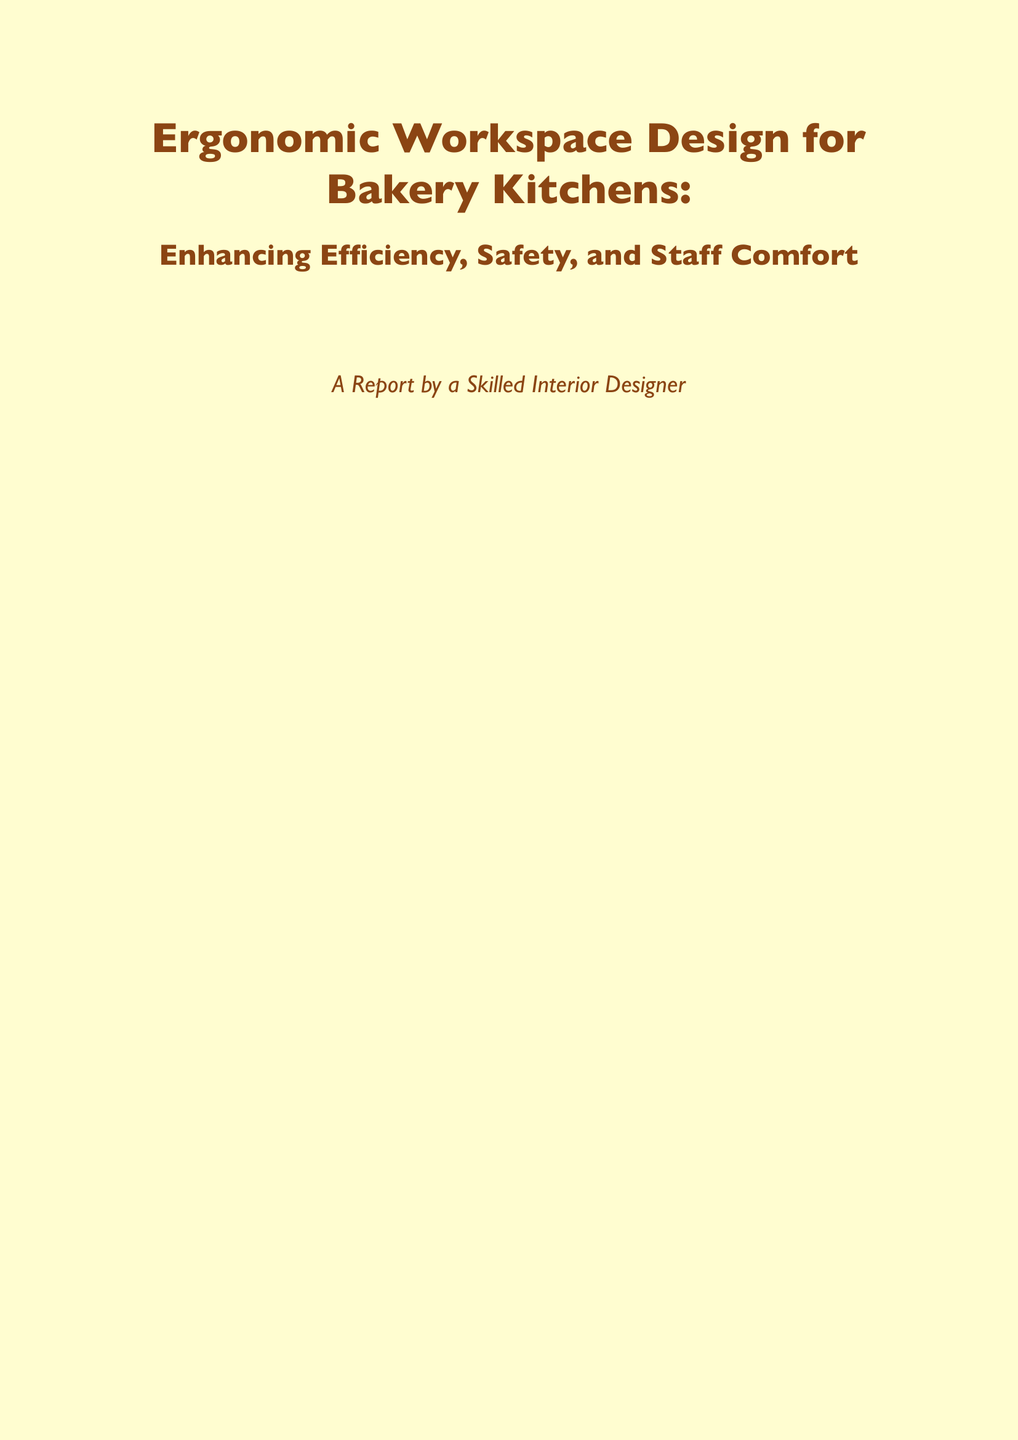What is the title of the report? The title of the report is presented at the beginning of the document.
Answer: Ergonomic Workspace Design for Bakery Kitchens: Enhancing Efficiency, Safety, and Staff Comfort What is the purpose of the report? The executive summary states that the report focuses on improving workflow efficiency, ensuring staff safety, and enhancing overall comfort.
Answer: Analyzes ergonomic design principles What is one feature of workstation design mentioned? The report lists adjustable work surfaces as a key feature under workstation design.
Answer: Adjustable Work Surfaces What type of flooring is recommended for safety? The document specifies a type of flooring in the safety measures section.
Answer: Non-Slip Flooring What are the two main concepts in layout optimization? The subsection titles indicate key concepts discussed in layout optimization.
Answer: Work Triangle Concept and Zoning What is a recommended storage solution? Storage solutions are presented in a section that discusses maximizing kitchen space.
Answer: Vertical Storage What is one recommendation given for staff training? The recommendations section includes several training measures to improve ergonomics.
Answer: Conduct ergonomic training sessions What type of lighting is suggested for workstations? The report under the lighting section specifies a type of lighting for workstations.
Answer: Adjustable LED task lighting What is covered in Appendix A? The appendices provide information about specific resources related to ergonomic assessment.
Answer: Ergonomic Assessment Checklist 